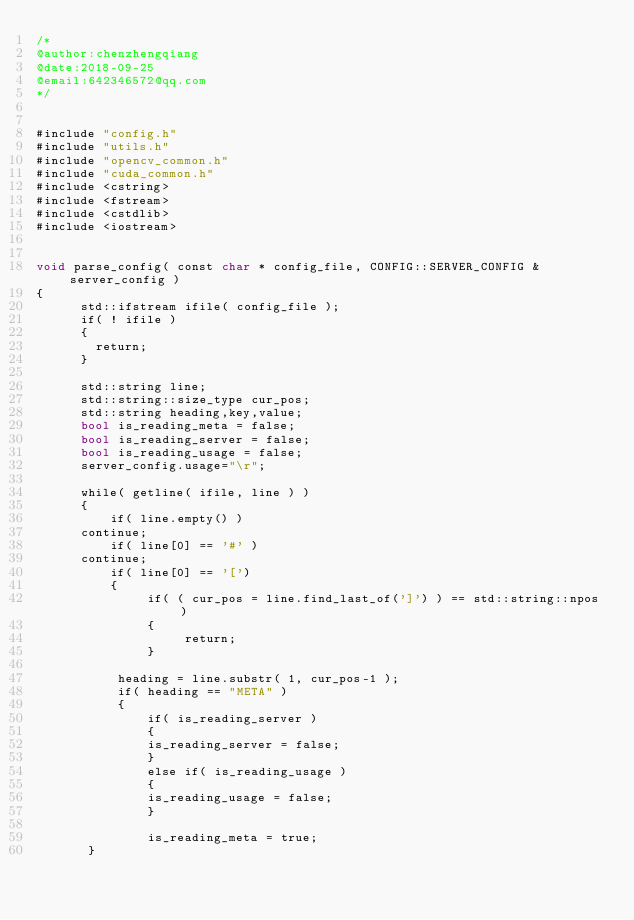Convert code to text. <code><loc_0><loc_0><loc_500><loc_500><_Cuda_>/*
@author:chenzhengqiang
@date:2018-09-25
@email:642346572@qq.com
*/


#include "config.h"
#include "utils.h"
#include "opencv_common.h"
#include "cuda_common.h"
#include <cstring>
#include <fstream>
#include <cstdlib>
#include <iostream>


void parse_config( const char * config_file, CONFIG::SERVER_CONFIG & server_config )
{
      std::ifstream ifile( config_file );
      if( ! ifile )
      {
        return;
      }

      std::string line;
      std::string::size_type cur_pos;
      std::string heading,key,value;
      bool is_reading_meta = false;
      bool is_reading_server = false;
      bool is_reading_usage = false;
      server_config.usage="\r";
	
      while( getline( ifile, line ) )
      {
          if( line.empty() )
	  continue;
          if( line[0] == '#' )
	  continue;
          if( line[0] == '[')
          {
               if( ( cur_pos = line.find_last_of(']') ) == std::string::npos )
               {
                    return;
               }
			
	       heading = line.substr( 1, cur_pos-1 );
	       if( heading == "META" )
	       {
	           if( is_reading_server )
	           {
		       is_reading_server = false;
	           }
	           else if( is_reading_usage )
	           {
		       is_reading_usage = false;
	           }
				
	           is_reading_meta = true;
	   }</code> 